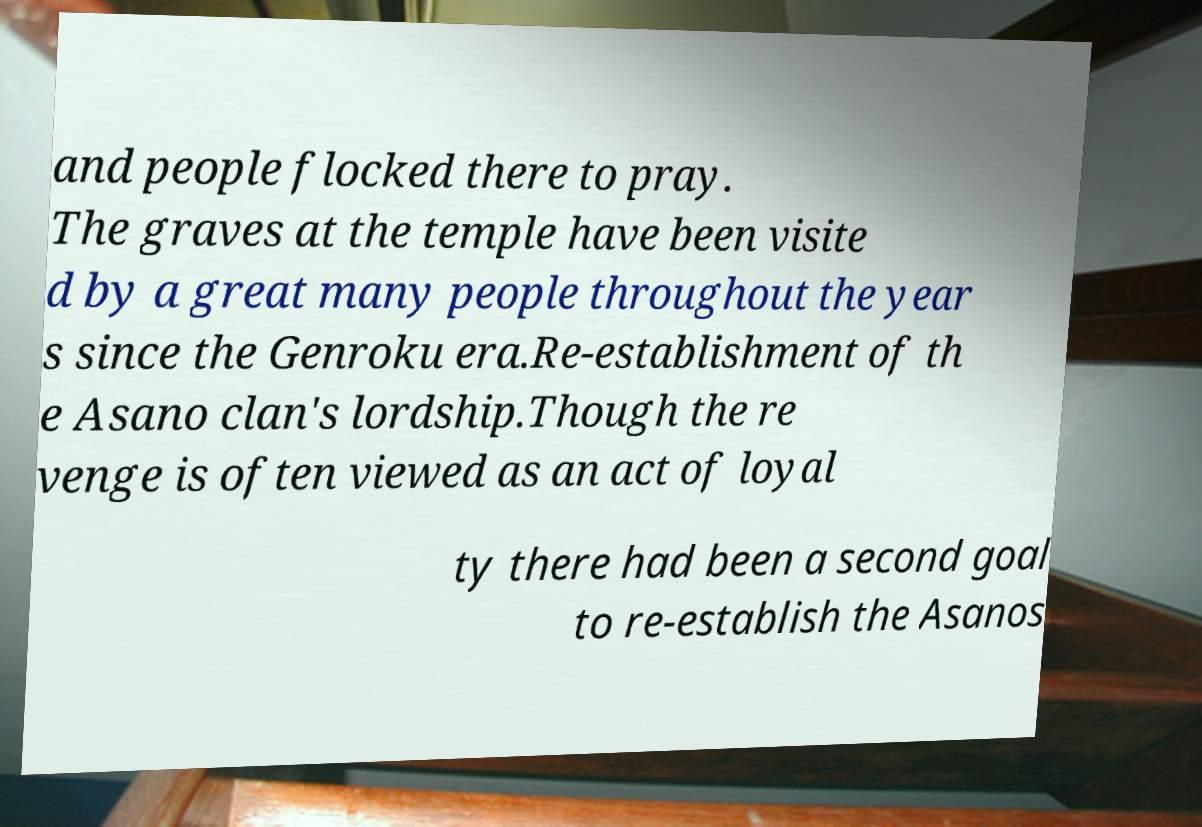Can you accurately transcribe the text from the provided image for me? and people flocked there to pray. The graves at the temple have been visite d by a great many people throughout the year s since the Genroku era.Re-establishment of th e Asano clan's lordship.Though the re venge is often viewed as an act of loyal ty there had been a second goal to re-establish the Asanos 